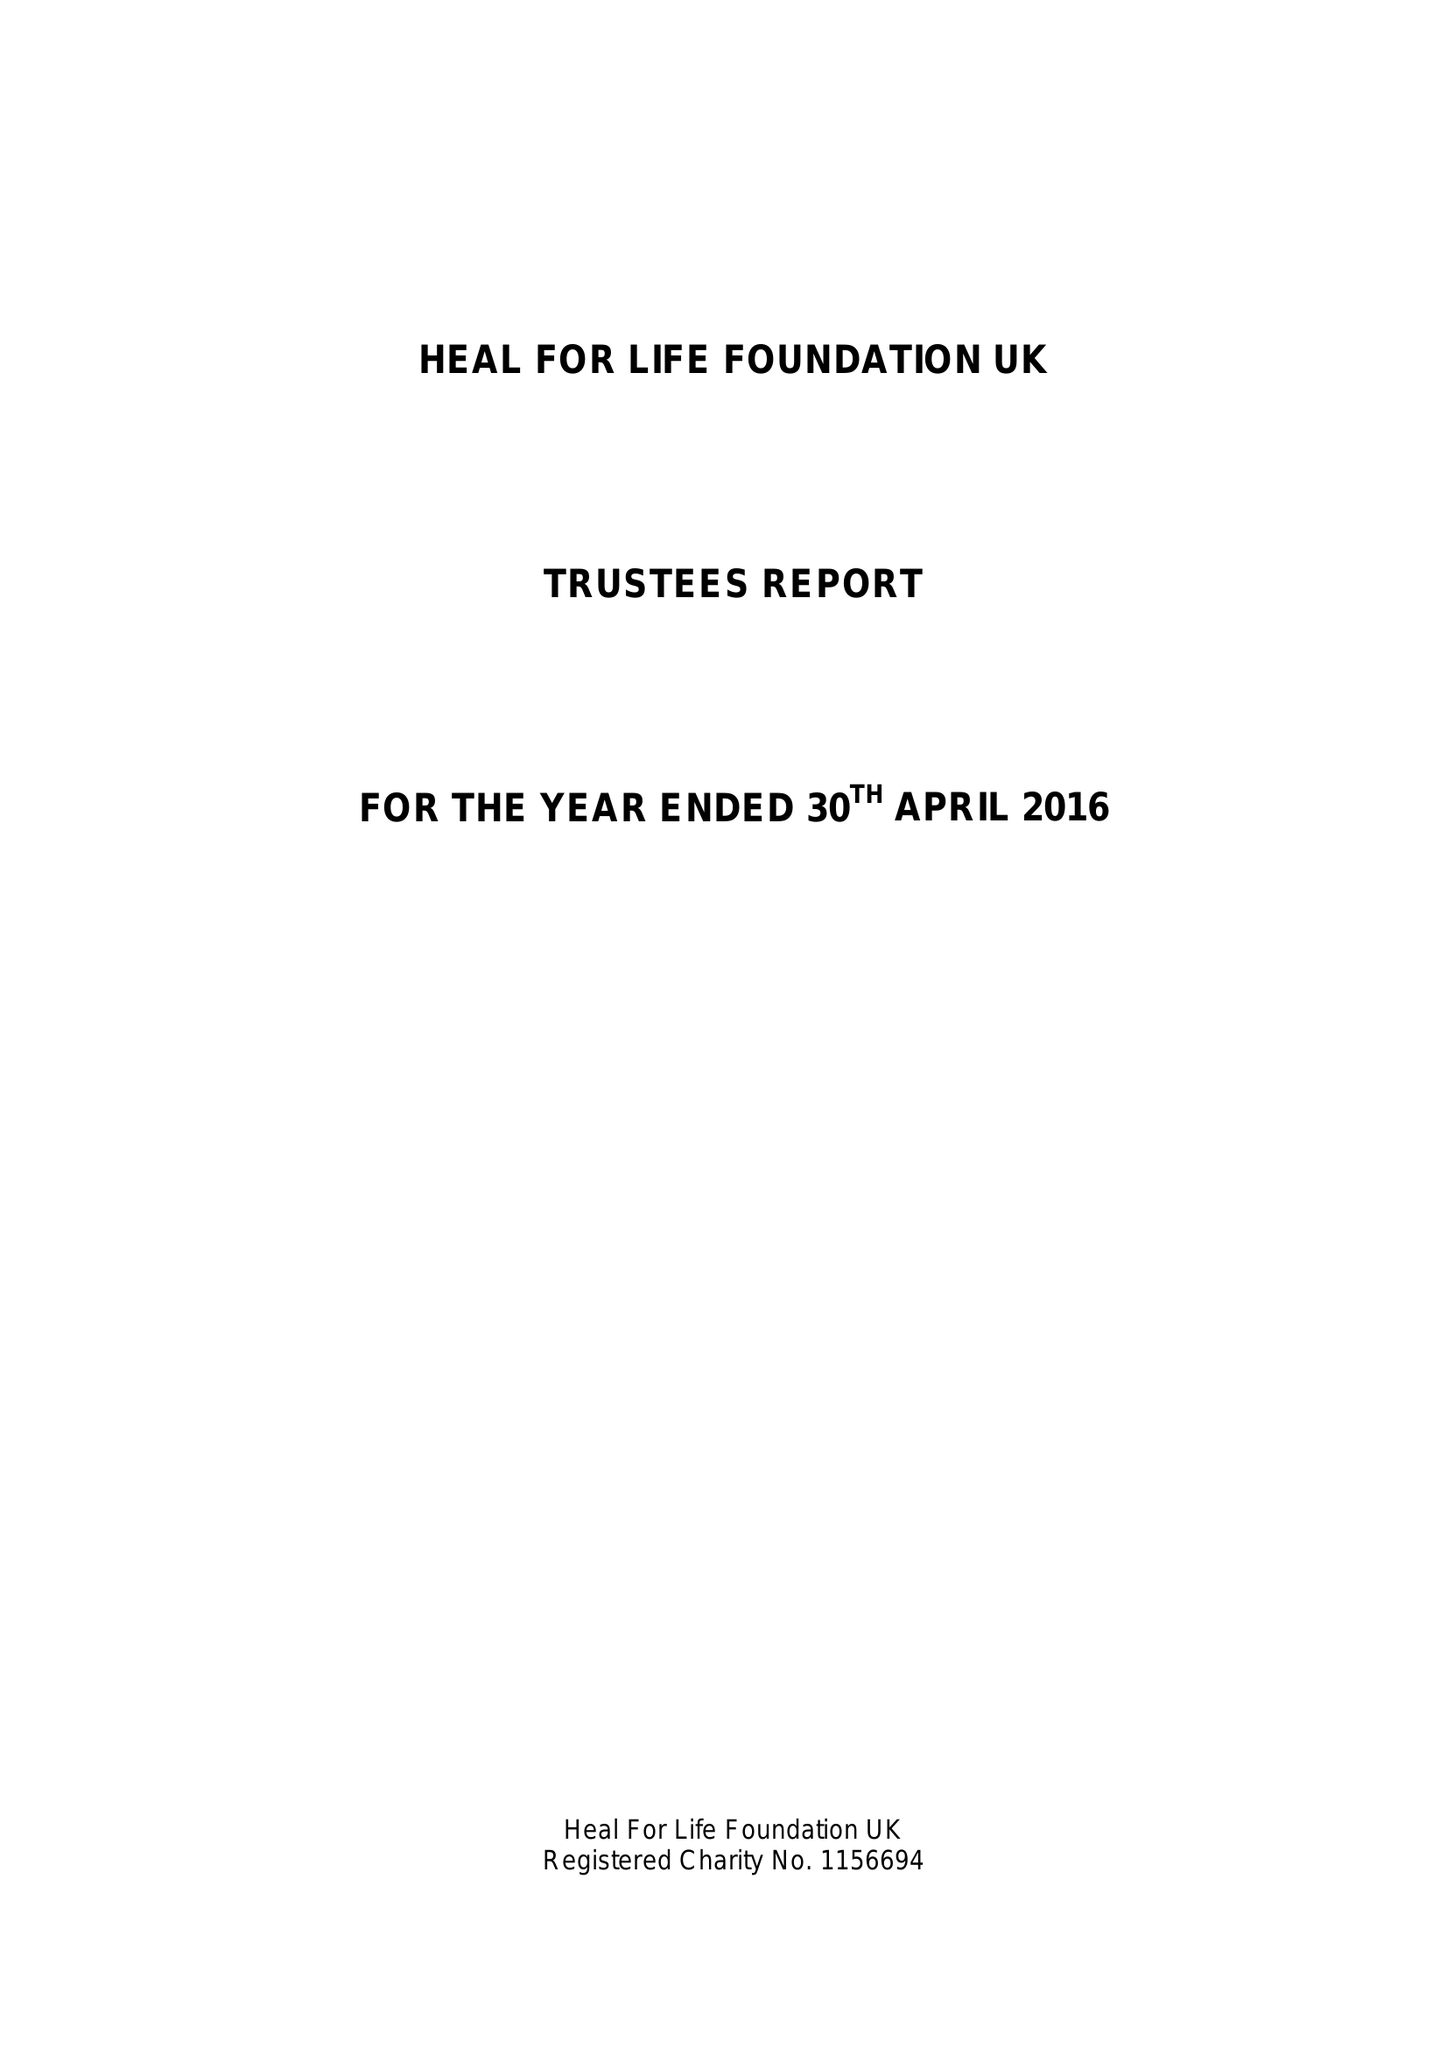What is the value for the address__post_town?
Answer the question using a single word or phrase. ASHFORD 